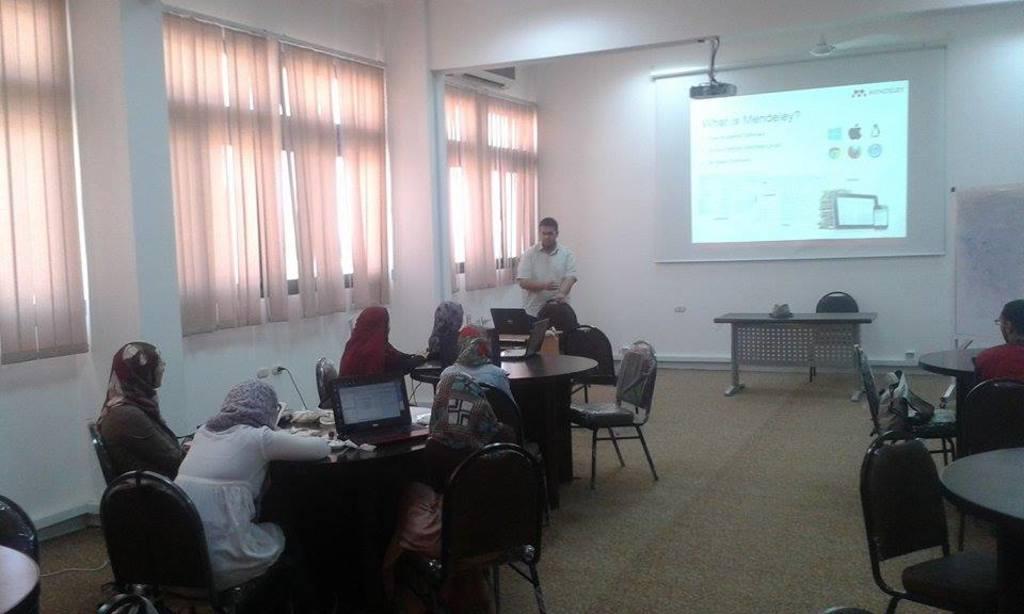Please provide a concise description of this image. In this picture we can see some persons are sitting on the chairs. These are the tables. On the table there are laptops. Here we can see a man who is standing on the floor. On the background there is a wall and this is screen. Here we can see curtains. 